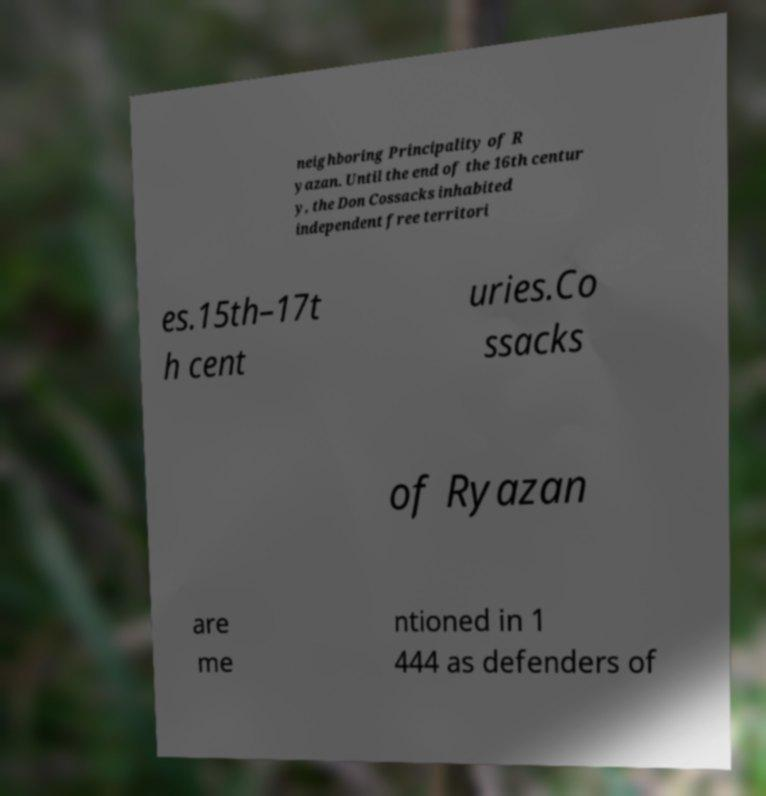Can you read and provide the text displayed in the image?This photo seems to have some interesting text. Can you extract and type it out for me? neighboring Principality of R yazan. Until the end of the 16th centur y, the Don Cossacks inhabited independent free territori es.15th–17t h cent uries.Co ssacks of Ryazan are me ntioned in 1 444 as defenders of 